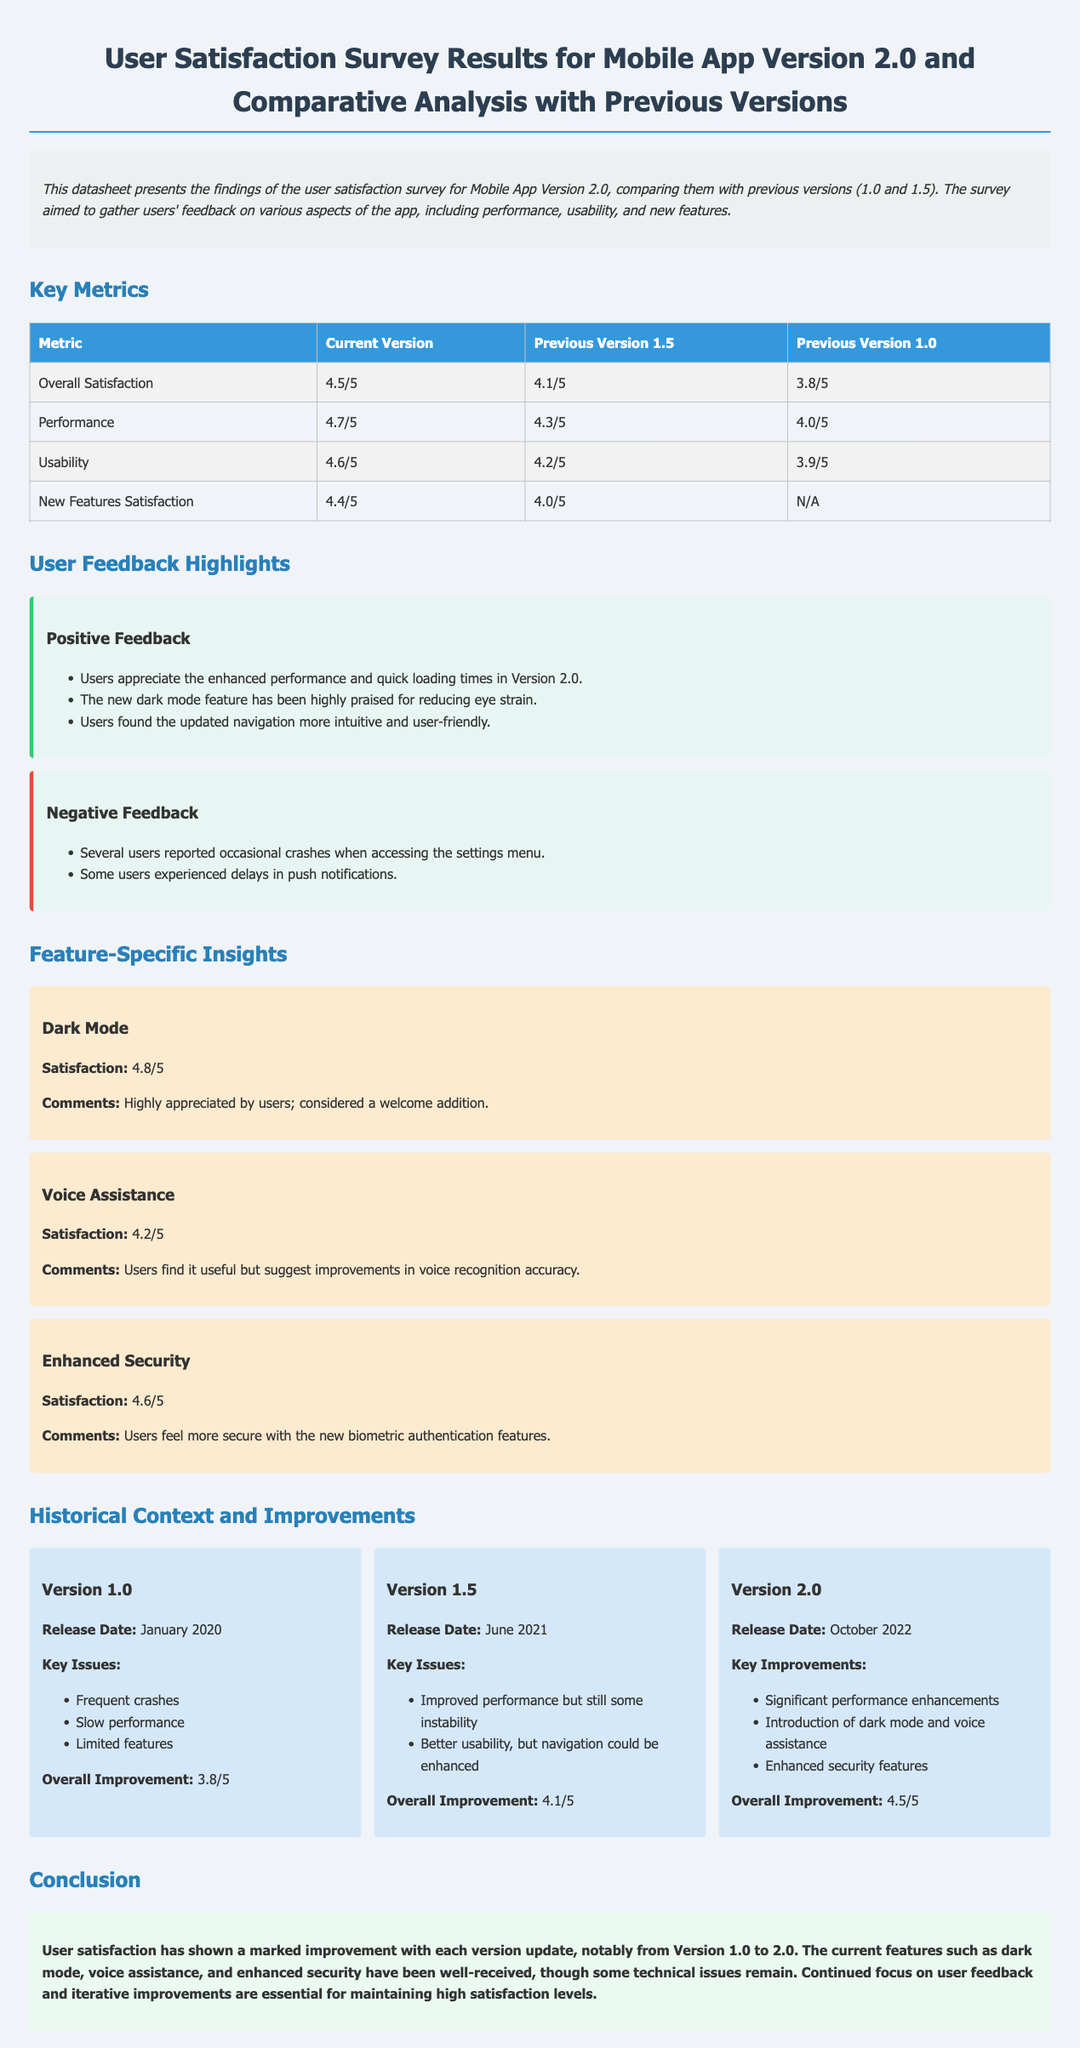What is the overall satisfaction rating for Version 2.0? The overall satisfaction rating is provided in the key metrics section under Current Version.
Answer: 4.5/5 What was the release date of Version 1.0? The release date for Version 1.0 is listed in the historical context section.
Answer: January 2020 What is the satisfaction rating for the dark mode feature? The satisfaction rating for dark mode is mentioned in the feature-specific insights.
Answer: 4.8/5 Which version introduced voice assistance? The version that introduced voice assistance is indicated in the historical context and improvements section.
Answer: Version 2.0 What is one negative feedback mentioned by users? Negative feedback items are provided in the user feedback highlights section.
Answer: Occasional crashes What was the overall improvement rating for Version 1.5? The overall improvement rating for Version 1.5 is listed in the historical context section.
Answer: 4.1/5 What are two key improvements of Version 2.0? Key improvements are detailed in the historical context and improvements section, and two examples can be selected from this content.
Answer: Dark mode and voice assistance How many metrics are compared in the key metrics table? This can be inferred from the number of rows in the key metrics table minus the header row.
Answer: 4 